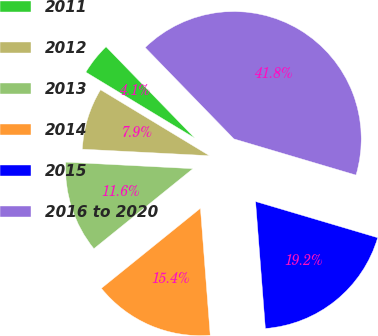Convert chart. <chart><loc_0><loc_0><loc_500><loc_500><pie_chart><fcel>2011<fcel>2012<fcel>2013<fcel>2014<fcel>2015<fcel>2016 to 2020<nl><fcel>4.07%<fcel>7.85%<fcel>11.63%<fcel>15.41%<fcel>19.19%<fcel>41.85%<nl></chart> 